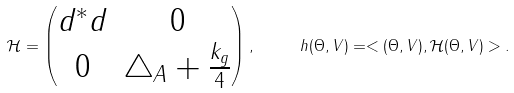Convert formula to latex. <formula><loc_0><loc_0><loc_500><loc_500>\mathcal { H } = \left ( \begin{matrix} d ^ { * } d & 0 \\ 0 & \triangle _ { A } + \frac { k _ { g } } { 4 } \end{matrix} \right ) , \quad \ h ( \Theta , V ) = < ( \Theta , V ) , \mathcal { H } ( \Theta , V ) > .</formula> 